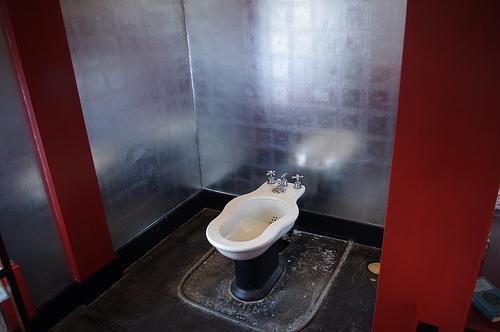How many toilets are in this picture?
Give a very brief answer. 1. 